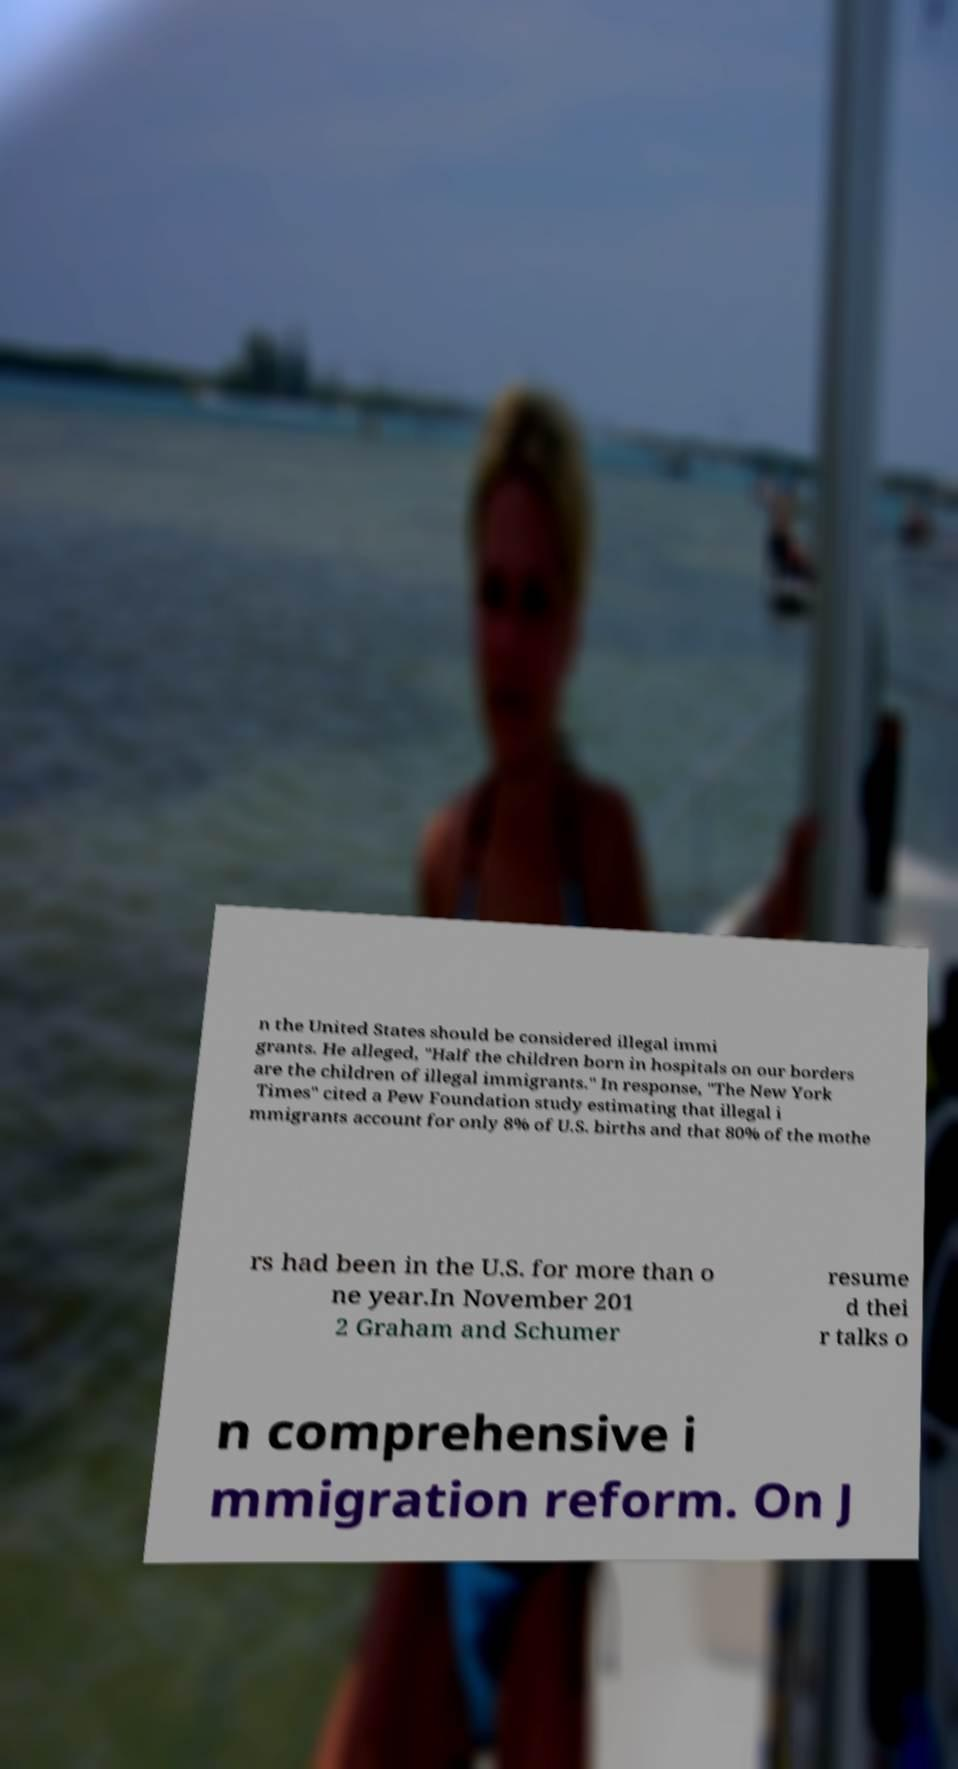I need the written content from this picture converted into text. Can you do that? n the United States should be considered illegal immi grants. He alleged, "Half the children born in hospitals on our borders are the children of illegal immigrants." In response, "The New York Times" cited a Pew Foundation study estimating that illegal i mmigrants account for only 8% of U.S. births and that 80% of the mothe rs had been in the U.S. for more than o ne year.In November 201 2 Graham and Schumer resume d thei r talks o n comprehensive i mmigration reform. On J 